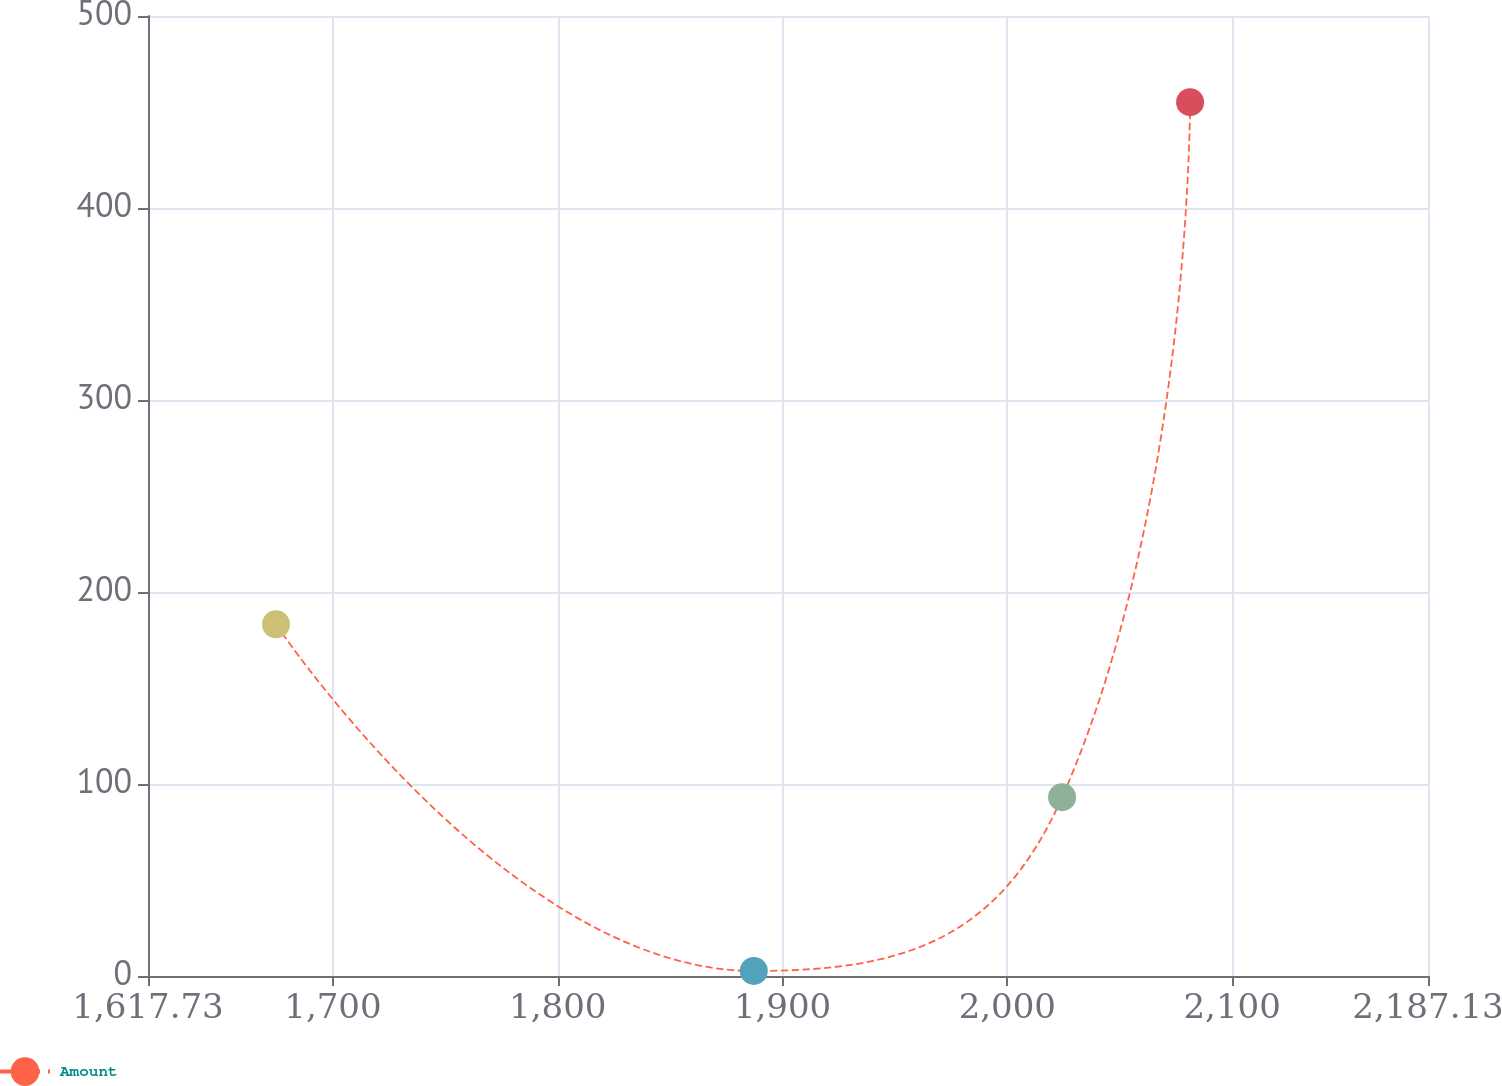<chart> <loc_0><loc_0><loc_500><loc_500><line_chart><ecel><fcel>Amount<nl><fcel>1674.67<fcel>183.17<nl><fcel>1887.22<fcel>2.62<nl><fcel>2024.36<fcel>93.12<nl><fcel>2081.3<fcel>455.11<nl><fcel>2244.07<fcel>47.87<nl></chart> 